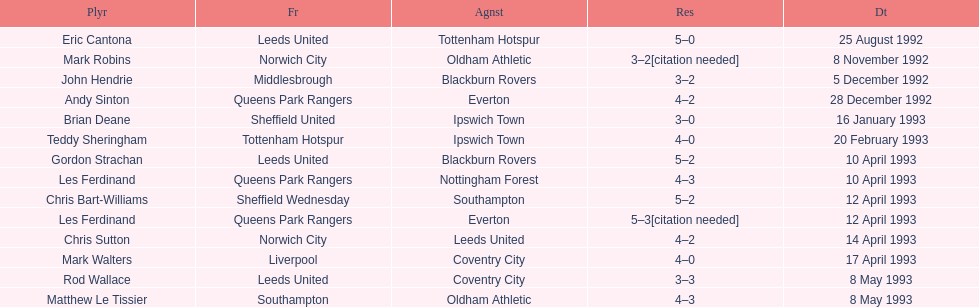Name the only player from france. Eric Cantona. 